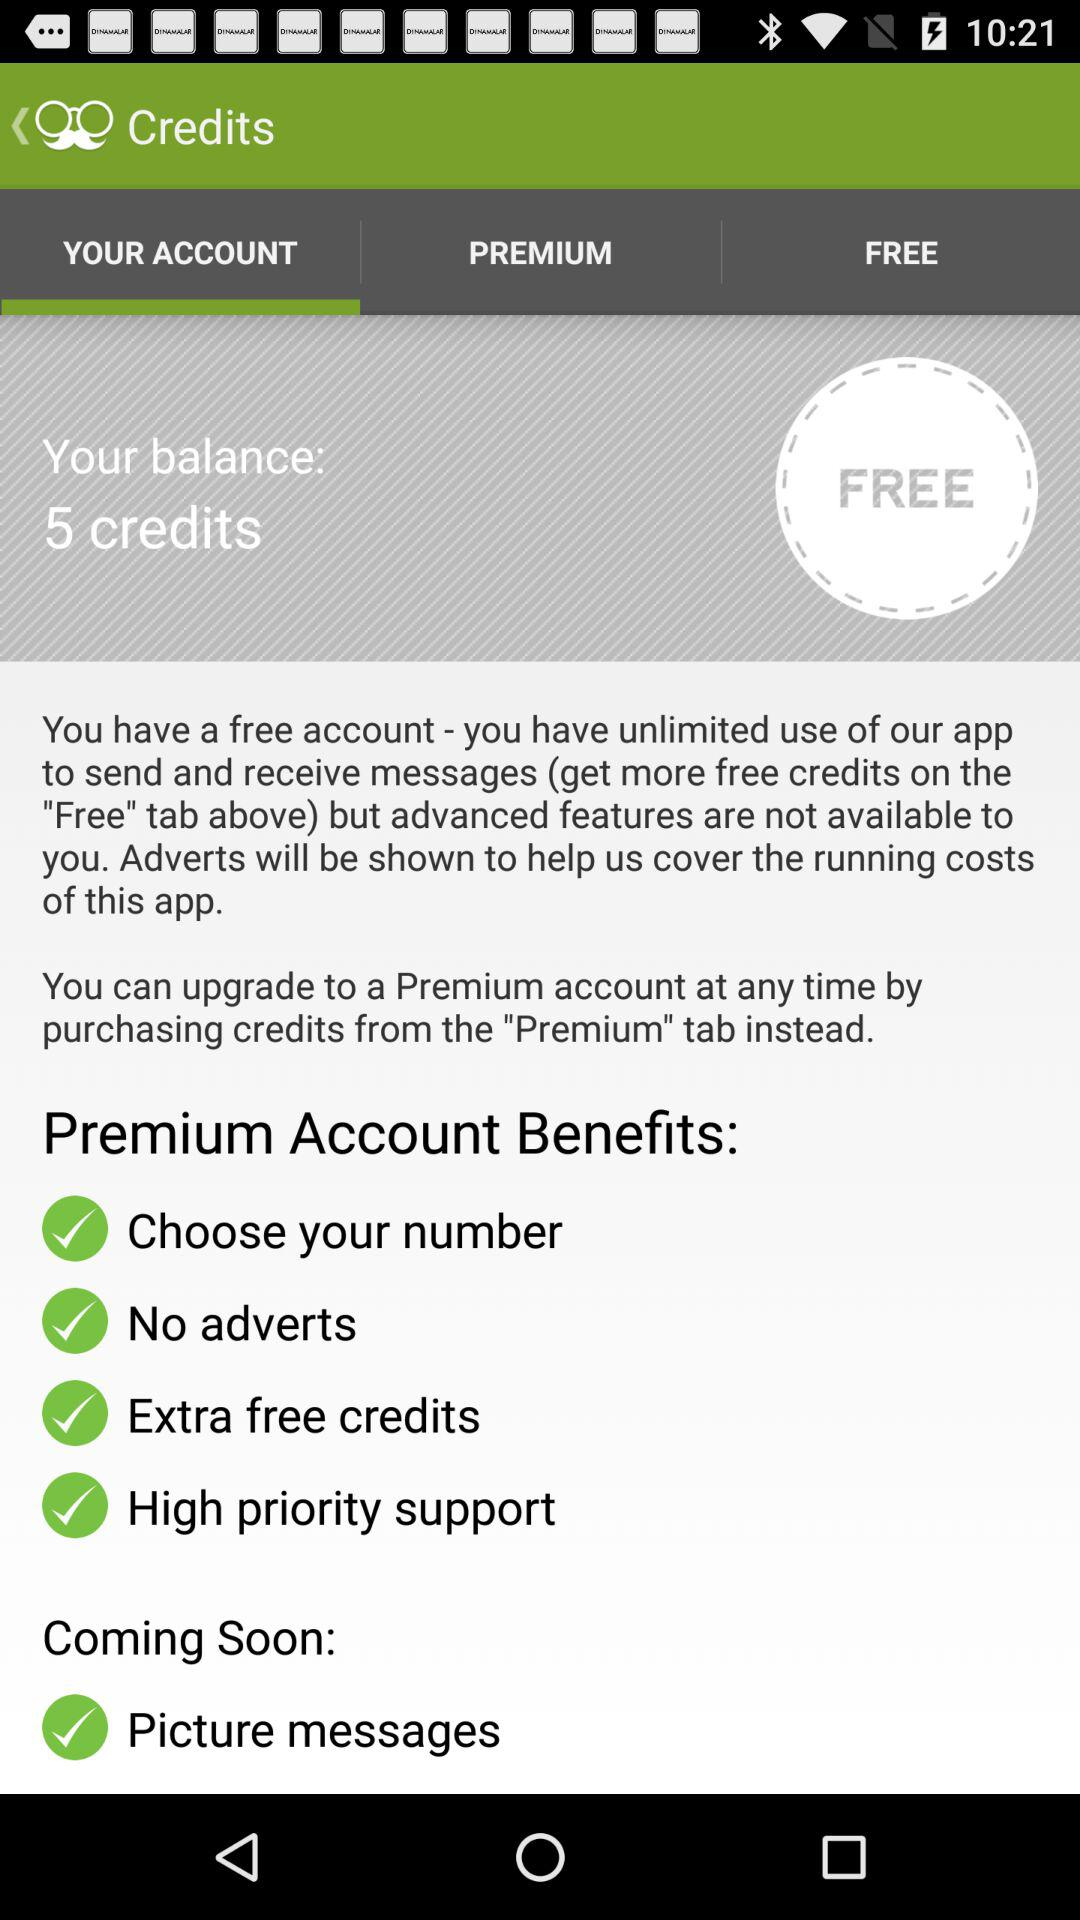How many credits are still available? There are still 5 credits available. 